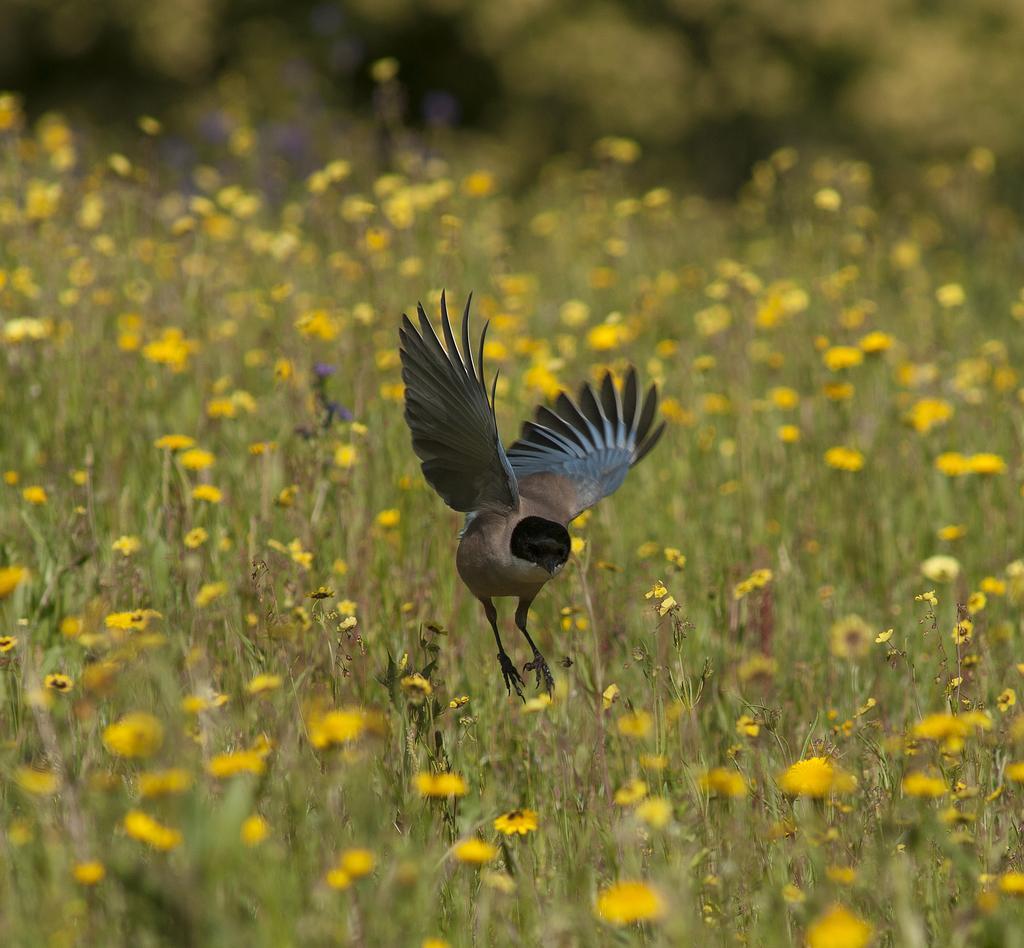Could you give a brief overview of what you see in this image? In the center of the image there is a bird. At the bottom of the image there are flower plants. 